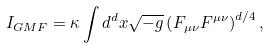<formula> <loc_0><loc_0><loc_500><loc_500>I _ { G M F } = \kappa \int d ^ { d } x \sqrt { - g } \left ( F _ { \mu \nu } F ^ { \mu \nu } \right ) ^ { d / 4 } ,</formula> 